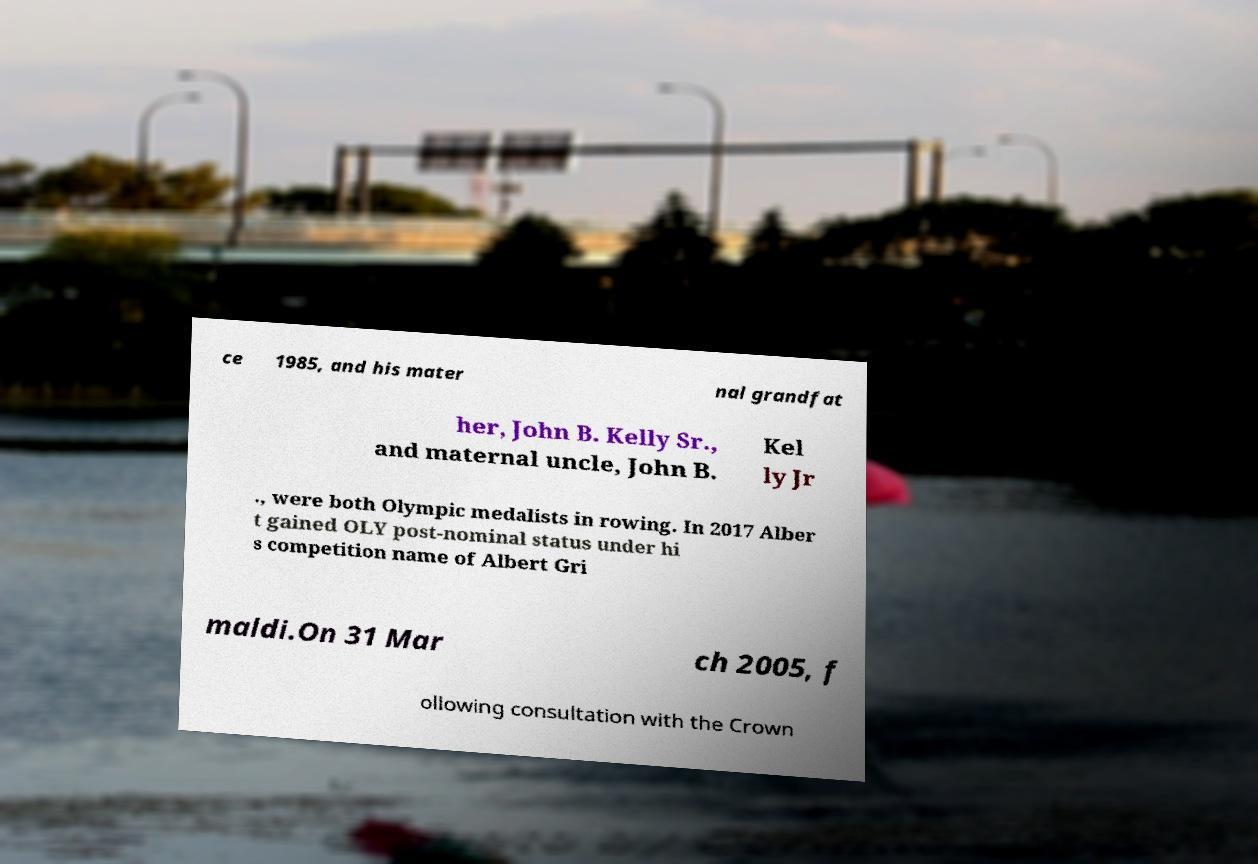Could you extract and type out the text from this image? ce 1985, and his mater nal grandfat her, John B. Kelly Sr., and maternal uncle, John B. Kel ly Jr ., were both Olympic medalists in rowing. In 2017 Alber t gained OLY post-nominal status under hi s competition name of Albert Gri maldi.On 31 Mar ch 2005, f ollowing consultation with the Crown 